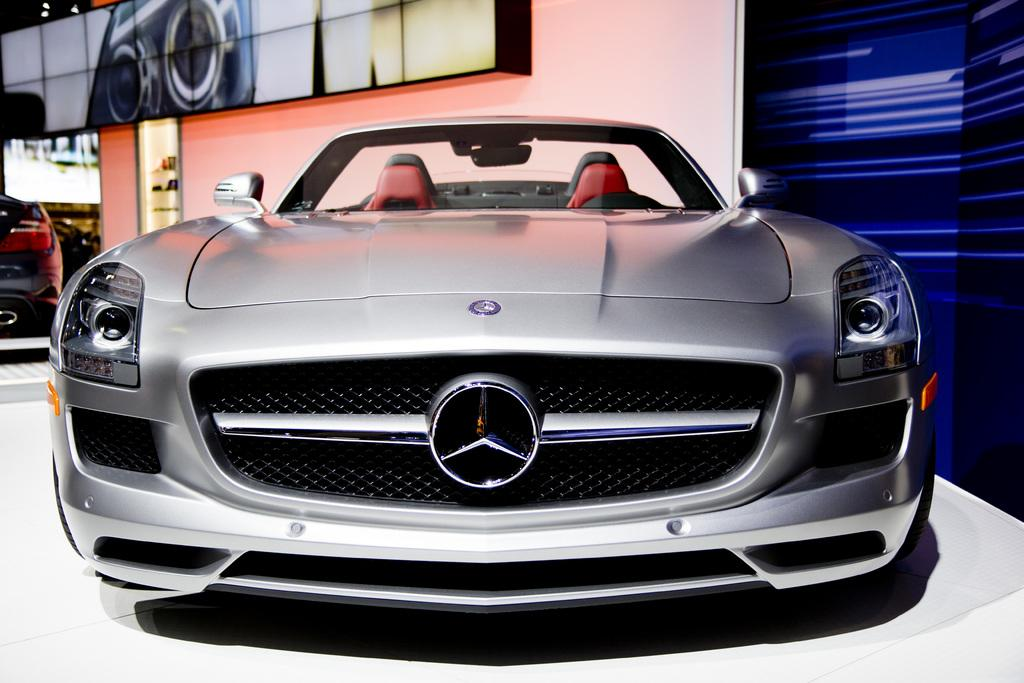What type of vehicles can be seen in the image? There are cars in the image. Can you describe any other objects or features in the background of the image? There is a digital screen on a wall in the background of the image. Where is the church located in the image? There is no church present in the image. What type of shade is provided by the desk in the image? There is no desk present in the image. 